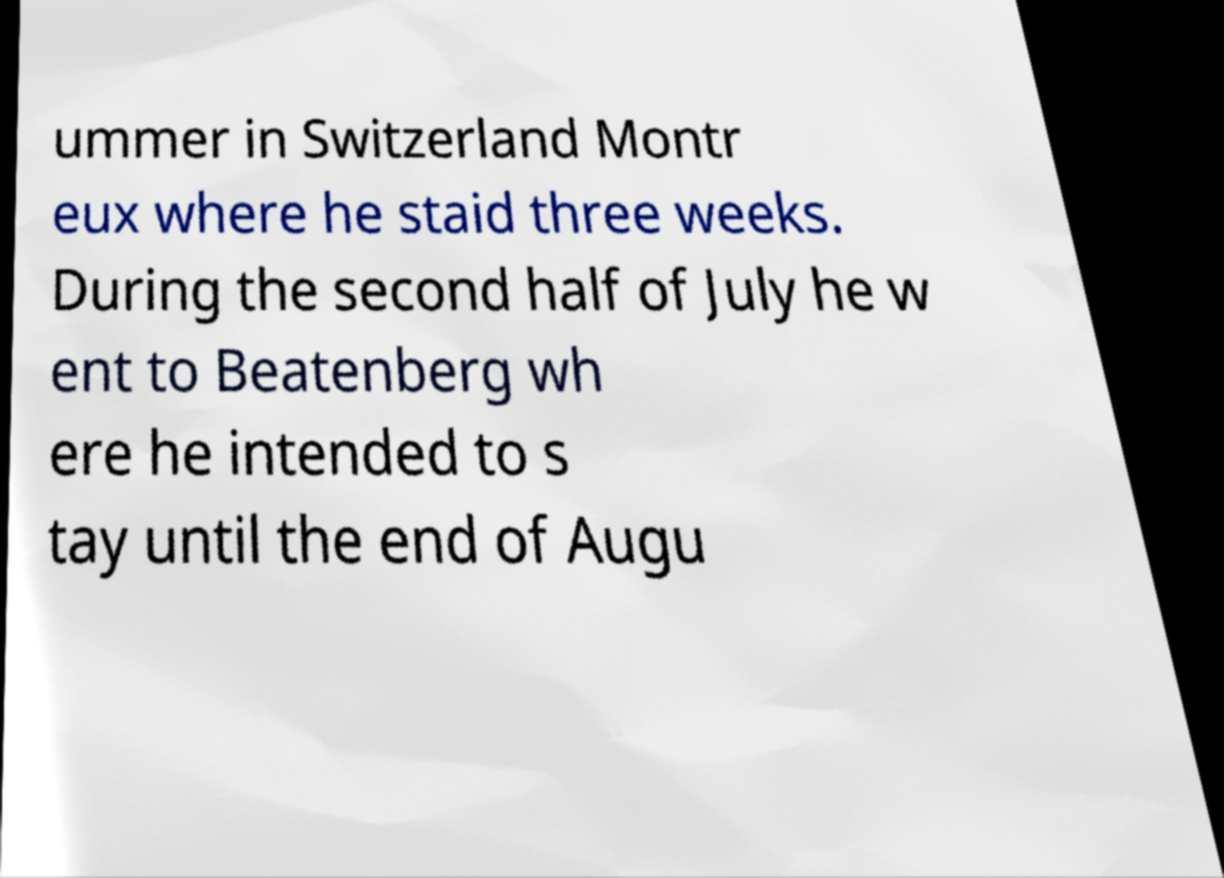I need the written content from this picture converted into text. Can you do that? ummer in Switzerland Montr eux where he staid three weeks. During the second half of July he w ent to Beatenberg wh ere he intended to s tay until the end of Augu 